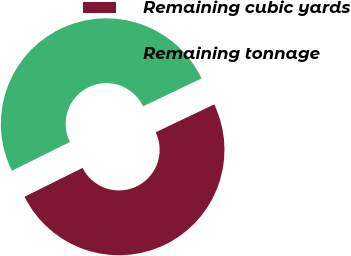Convert chart. <chart><loc_0><loc_0><loc_500><loc_500><pie_chart><fcel>Remaining cubic yards<fcel>Remaining tonnage<nl><fcel>49.73%<fcel>50.27%<nl></chart> 